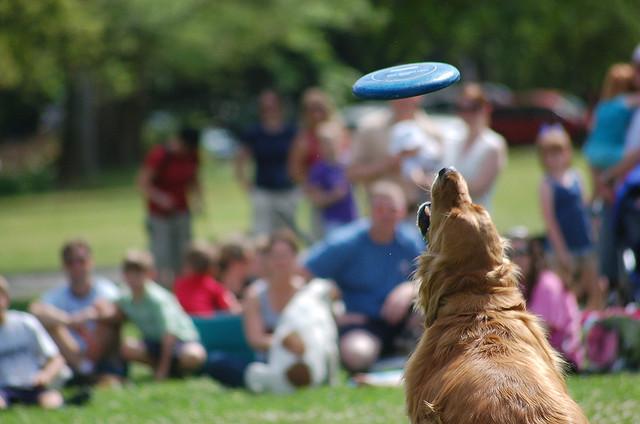What color is the Frisbee?
Give a very brief answer. Blue. Where is the dog?
Concise answer only. Park. How many dogs?
Write a very short answer. 2. 